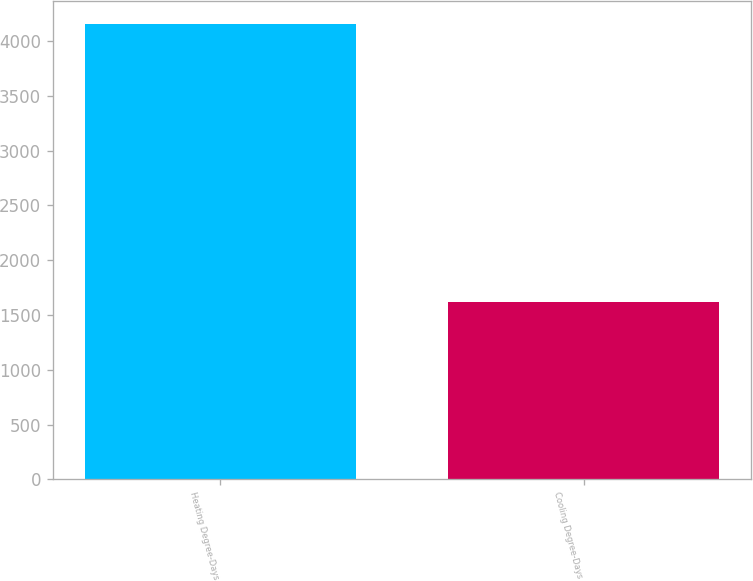Convert chart. <chart><loc_0><loc_0><loc_500><loc_500><bar_chart><fcel>Heating Degree-Days<fcel>Cooling Degree-Days<nl><fcel>4157<fcel>1617<nl></chart> 